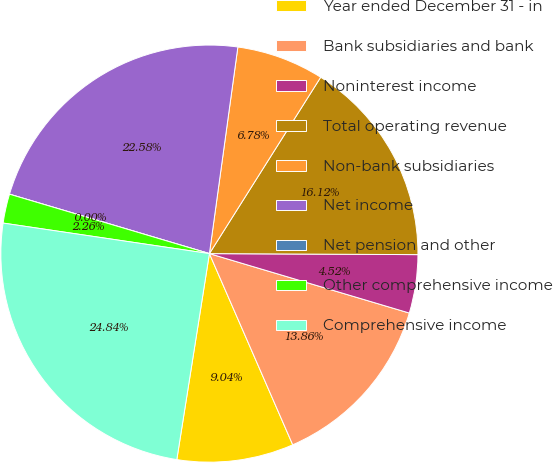Convert chart to OTSL. <chart><loc_0><loc_0><loc_500><loc_500><pie_chart><fcel>Year ended December 31 - in<fcel>Bank subsidiaries and bank<fcel>Noninterest income<fcel>Total operating revenue<fcel>Non-bank subsidiaries<fcel>Net income<fcel>Net pension and other<fcel>Other comprehensive income<fcel>Comprehensive income<nl><fcel>9.04%<fcel>13.86%<fcel>4.52%<fcel>16.12%<fcel>6.78%<fcel>22.58%<fcel>0.0%<fcel>2.26%<fcel>24.84%<nl></chart> 